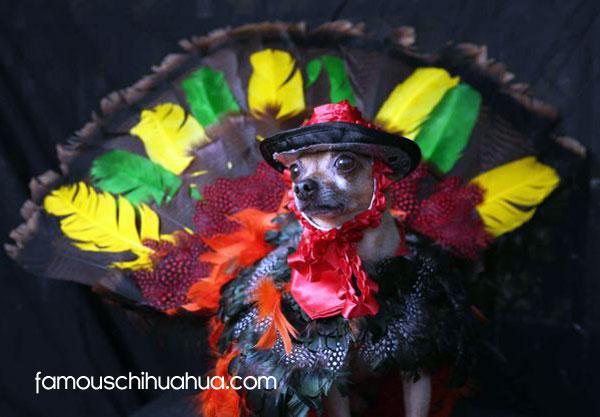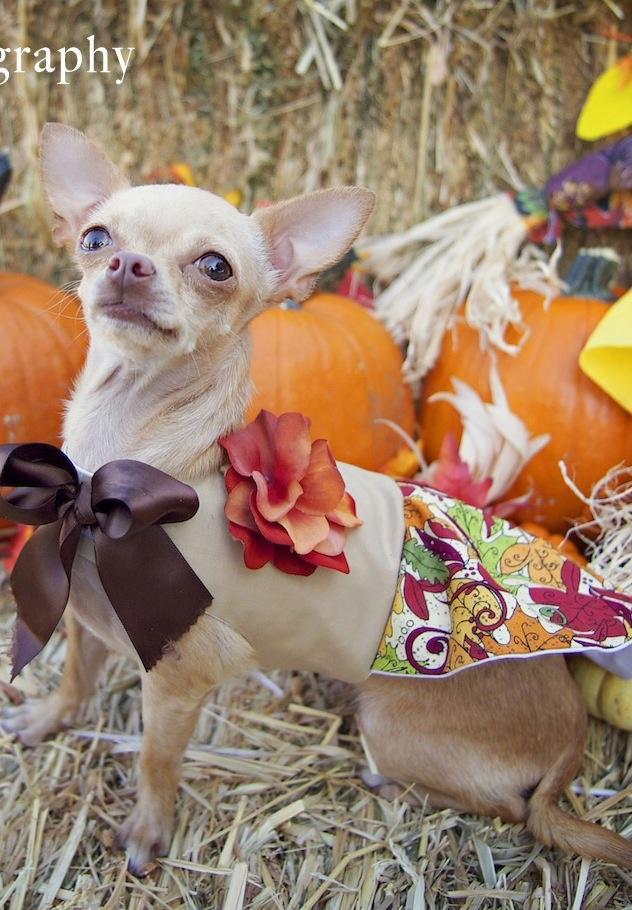The first image is the image on the left, the second image is the image on the right. Evaluate the accuracy of this statement regarding the images: "There is a chihuahua that is wearing a costume in each image.". Is it true? Answer yes or no. Yes. The first image is the image on the left, the second image is the image on the right. Examine the images to the left and right. Is the description "The dog in the image on the left is sitting before a plate of human food." accurate? Answer yes or no. No. 